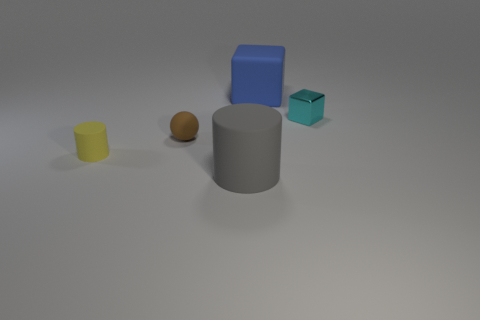Is there any other thing that has the same shape as the small brown rubber thing?
Your response must be concise. No. There is a block that is on the right side of the large rubber thing that is behind the rubber ball; is there a small cyan object that is behind it?
Ensure brevity in your answer.  No. There is a cylinder on the right side of the yellow object; does it have the same size as the ball?
Offer a very short reply. No. How many cyan matte cylinders have the same size as the brown rubber object?
Your response must be concise. 0. Does the ball have the same color as the small shiny block?
Provide a short and direct response. No. What is the shape of the big gray rubber object?
Your answer should be very brief. Cylinder. Is there a tiny cube that has the same color as the small cylinder?
Ensure brevity in your answer.  No. Are there more large rubber cylinders that are behind the gray object than yellow rubber things?
Ensure brevity in your answer.  No. Does the tiny metallic object have the same shape as the big object left of the large blue thing?
Offer a very short reply. No. Are any big cylinders visible?
Give a very brief answer. Yes. 